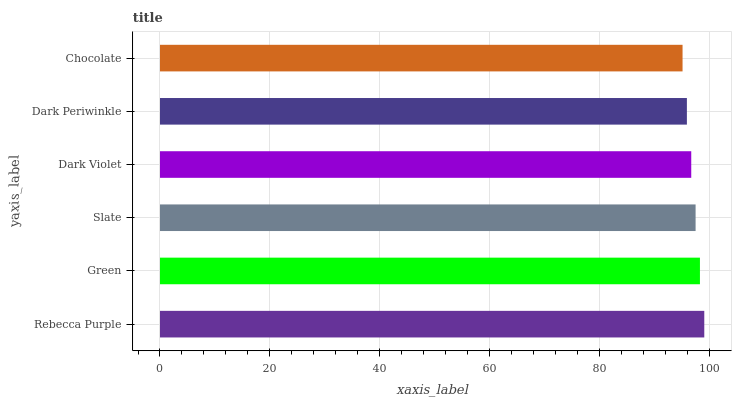Is Chocolate the minimum?
Answer yes or no. Yes. Is Rebecca Purple the maximum?
Answer yes or no. Yes. Is Green the minimum?
Answer yes or no. No. Is Green the maximum?
Answer yes or no. No. Is Rebecca Purple greater than Green?
Answer yes or no. Yes. Is Green less than Rebecca Purple?
Answer yes or no. Yes. Is Green greater than Rebecca Purple?
Answer yes or no. No. Is Rebecca Purple less than Green?
Answer yes or no. No. Is Slate the high median?
Answer yes or no. Yes. Is Dark Violet the low median?
Answer yes or no. Yes. Is Chocolate the high median?
Answer yes or no. No. Is Dark Periwinkle the low median?
Answer yes or no. No. 